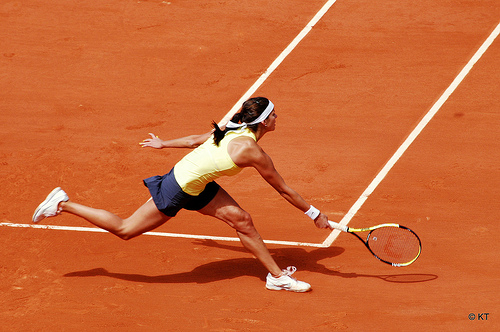Which side of the image is the tennis racket on? The tennis racket is on the right side of the image, held expertly in action. 